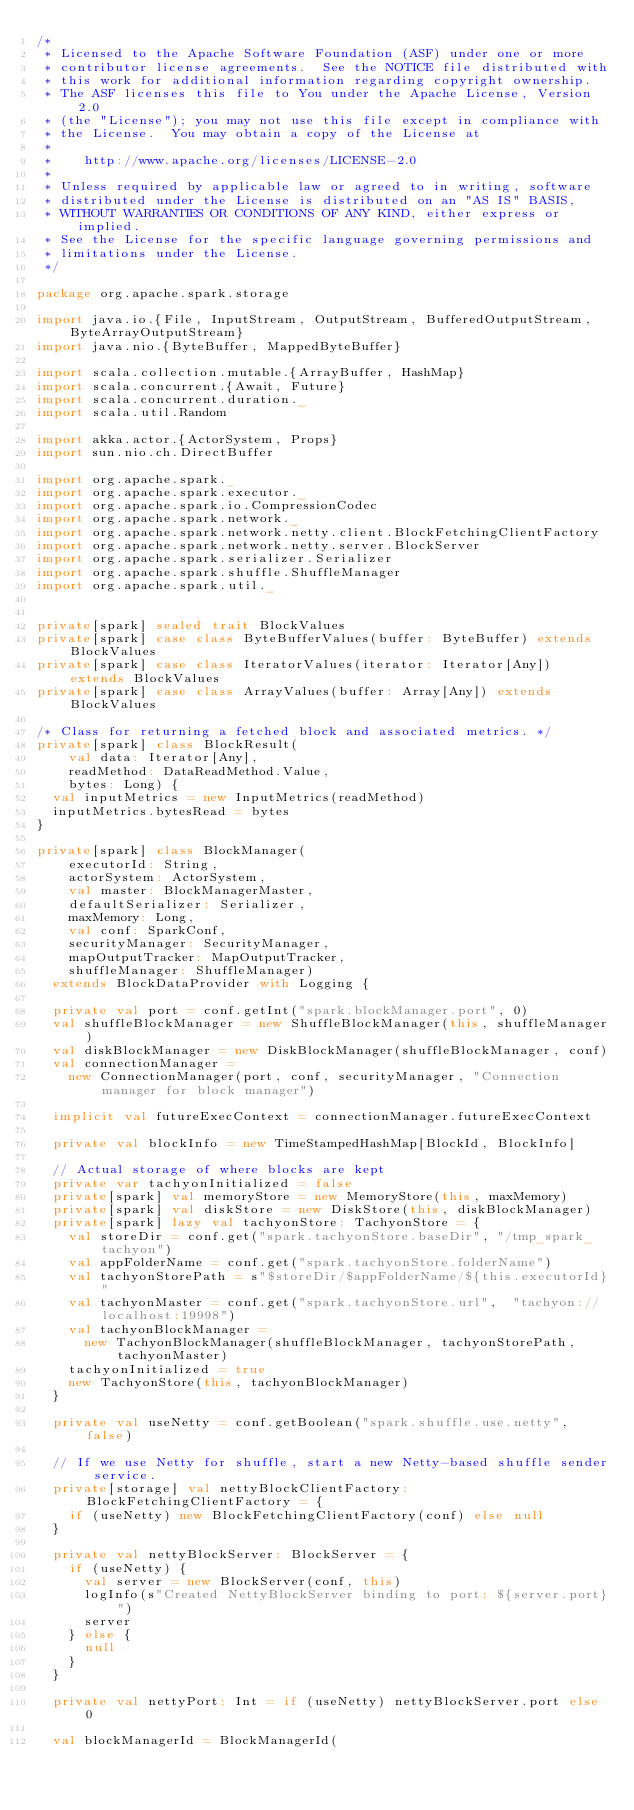Convert code to text. <code><loc_0><loc_0><loc_500><loc_500><_Scala_>/*
 * Licensed to the Apache Software Foundation (ASF) under one or more
 * contributor license agreements.  See the NOTICE file distributed with
 * this work for additional information regarding copyright ownership.
 * The ASF licenses this file to You under the Apache License, Version 2.0
 * (the "License"); you may not use this file except in compliance with
 * the License.  You may obtain a copy of the License at
 *
 *    http://www.apache.org/licenses/LICENSE-2.0
 *
 * Unless required by applicable law or agreed to in writing, software
 * distributed under the License is distributed on an "AS IS" BASIS,
 * WITHOUT WARRANTIES OR CONDITIONS OF ANY KIND, either express or implied.
 * See the License for the specific language governing permissions and
 * limitations under the License.
 */

package org.apache.spark.storage

import java.io.{File, InputStream, OutputStream, BufferedOutputStream, ByteArrayOutputStream}
import java.nio.{ByteBuffer, MappedByteBuffer}

import scala.collection.mutable.{ArrayBuffer, HashMap}
import scala.concurrent.{Await, Future}
import scala.concurrent.duration._
import scala.util.Random

import akka.actor.{ActorSystem, Props}
import sun.nio.ch.DirectBuffer

import org.apache.spark._
import org.apache.spark.executor._
import org.apache.spark.io.CompressionCodec
import org.apache.spark.network._
import org.apache.spark.network.netty.client.BlockFetchingClientFactory
import org.apache.spark.network.netty.server.BlockServer
import org.apache.spark.serializer.Serializer
import org.apache.spark.shuffle.ShuffleManager
import org.apache.spark.util._


private[spark] sealed trait BlockValues
private[spark] case class ByteBufferValues(buffer: ByteBuffer) extends BlockValues
private[spark] case class IteratorValues(iterator: Iterator[Any]) extends BlockValues
private[spark] case class ArrayValues(buffer: Array[Any]) extends BlockValues

/* Class for returning a fetched block and associated metrics. */
private[spark] class BlockResult(
    val data: Iterator[Any],
    readMethod: DataReadMethod.Value,
    bytes: Long) {
  val inputMetrics = new InputMetrics(readMethod)
  inputMetrics.bytesRead = bytes
}

private[spark] class BlockManager(
    executorId: String,
    actorSystem: ActorSystem,
    val master: BlockManagerMaster,
    defaultSerializer: Serializer,
    maxMemory: Long,
    val conf: SparkConf,
    securityManager: SecurityManager,
    mapOutputTracker: MapOutputTracker,
    shuffleManager: ShuffleManager)
  extends BlockDataProvider with Logging {

  private val port = conf.getInt("spark.blockManager.port", 0)
  val shuffleBlockManager = new ShuffleBlockManager(this, shuffleManager)
  val diskBlockManager = new DiskBlockManager(shuffleBlockManager, conf)
  val connectionManager =
    new ConnectionManager(port, conf, securityManager, "Connection manager for block manager")

  implicit val futureExecContext = connectionManager.futureExecContext

  private val blockInfo = new TimeStampedHashMap[BlockId, BlockInfo]

  // Actual storage of where blocks are kept
  private var tachyonInitialized = false
  private[spark] val memoryStore = new MemoryStore(this, maxMemory)
  private[spark] val diskStore = new DiskStore(this, diskBlockManager)
  private[spark] lazy val tachyonStore: TachyonStore = {
    val storeDir = conf.get("spark.tachyonStore.baseDir", "/tmp_spark_tachyon")
    val appFolderName = conf.get("spark.tachyonStore.folderName")
    val tachyonStorePath = s"$storeDir/$appFolderName/${this.executorId}"
    val tachyonMaster = conf.get("spark.tachyonStore.url",  "tachyon://localhost:19998")
    val tachyonBlockManager =
      new TachyonBlockManager(shuffleBlockManager, tachyonStorePath, tachyonMaster)
    tachyonInitialized = true
    new TachyonStore(this, tachyonBlockManager)
  }

  private val useNetty = conf.getBoolean("spark.shuffle.use.netty", false)

  // If we use Netty for shuffle, start a new Netty-based shuffle sender service.
  private[storage] val nettyBlockClientFactory: BlockFetchingClientFactory = {
    if (useNetty) new BlockFetchingClientFactory(conf) else null
  }

  private val nettyBlockServer: BlockServer = {
    if (useNetty) {
      val server = new BlockServer(conf, this)
      logInfo(s"Created NettyBlockServer binding to port: ${server.port}")
      server
    } else {
      null
    }
  }

  private val nettyPort: Int = if (useNetty) nettyBlockServer.port else 0

  val blockManagerId = BlockManagerId(</code> 